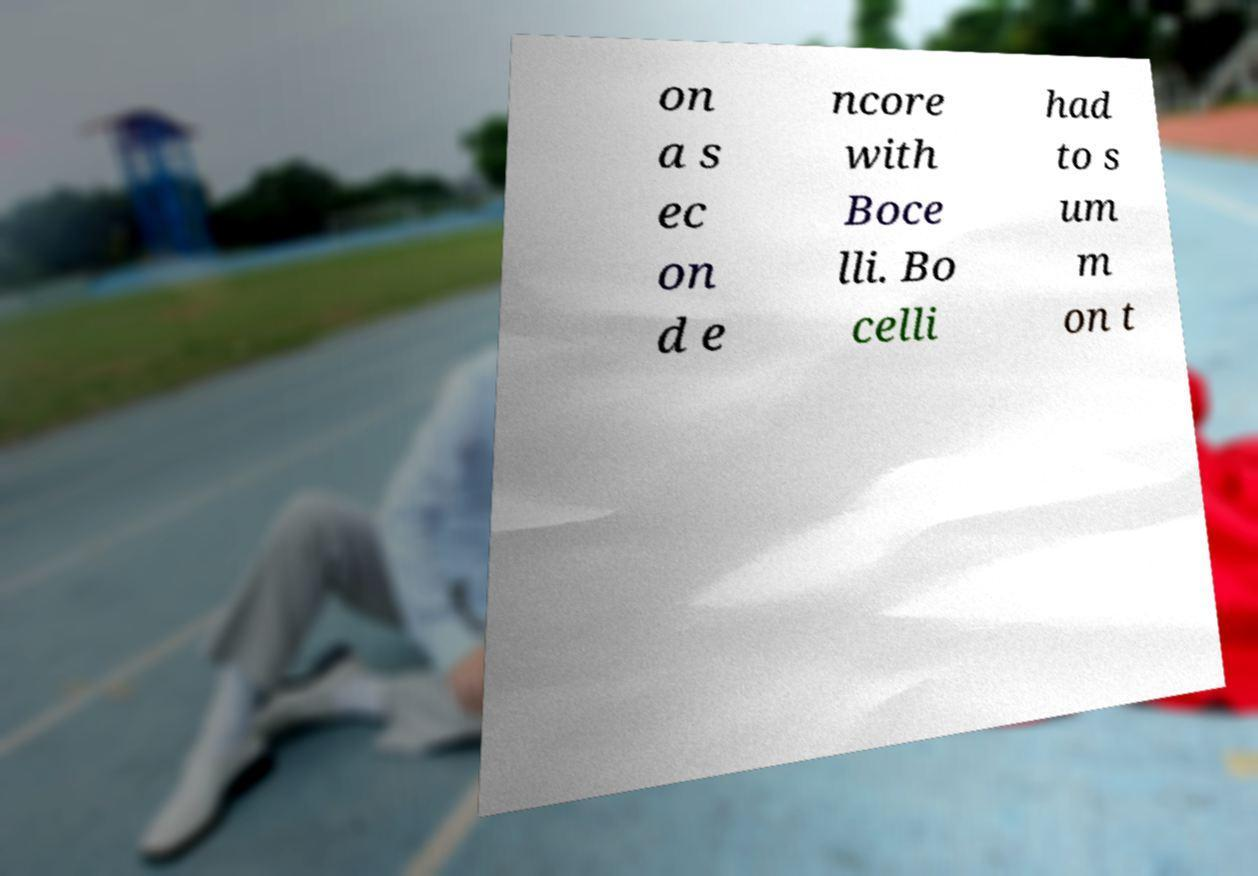For documentation purposes, I need the text within this image transcribed. Could you provide that? on a s ec on d e ncore with Boce lli. Bo celli had to s um m on t 